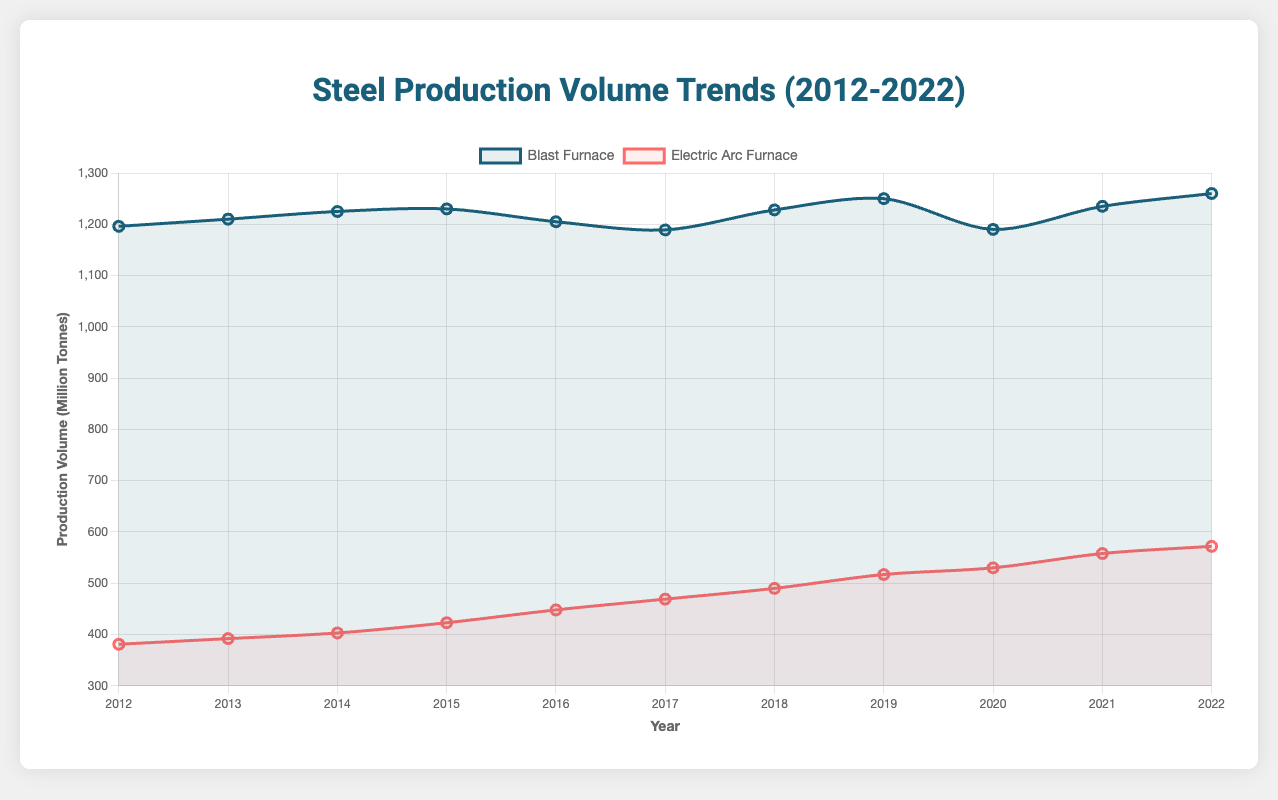What is the overall trend observed for the Electric Arc Furnace production volume from 2012 to 2022? The Electric Arc Furnace production volume shows a steady increase each year from 381 million tonnes in 2012 to 572 million tonnes in 2022.
Answer: Steady increase Which technology type had the highest production volume in 2022? To determine which technology type had the highest production volume, compare the values for 2022: Blast Furnace is 1260 million tonnes and Electric Arc Furnace is 572 million tonnes. The higher value is for Blast Furnace.
Answer: Blast Furnace By how much did the production volume of the Blast Furnace change from 2017 to 2022? Subtract the 2017 value (1189 million tonnes) from the 2022 value (1260 million tonnes) to find the change: 1260 - 1189 = 71 million tonnes.
Answer: 71 million tonnes Which year had the largest increase in production volume for Electric Arc Furnace compared to the previous year? Calculate the yearly differences for Electric Arc Furnace production volumes and identify the maximum increase: The largest increase is from 2019 to 2020 (530 - 517 = 13 million tonnes).
Answer: 2020 How does the production volume trend for Blast Furnace compare between 2016 and 2017? Comparing the values, Blast Furnace production decreased from 2016 (1205 million tonnes) to 2017 (1189 million tonnes).
Answer: Decreased What is the average production volume for Electric Arc Furnace over the decade (2012-2022)? Sum all Electric Arc Furnace production volumes from 2012 to 2022 and divide by the number of years: (381 + 392 + 403 + 423 + 448 + 469 + 490 + 517 + 530 + 558 + 572) / 11 = 456.18 million tonnes (approx).
Answer: 456.18 million tonnes What technological type had a higher production increase from 2019 to 2022? Calculate the difference in production for both technologies between 2019 and 2022: Blast Furnace (1260 - 1250 = 10 million tonnes) and Electric Arc Furnace (572 - 517 = 55 million tonnes). Electric Arc Furnace has a higher increase.
Answer: Electric Arc Furnace During which year did the Blast Furnace production volume fall below 1200 million tonnes? Examine each year's production volume for Blast Furnace. In 2020, it fell to 1190 million tonnes.
Answer: 2020 In 2015, what was the difference in production volumes between the two technology types? Subtract the Electric Arc Furnace value from the Blast Furnace value in 2015: 1230 - 423 = 807 million tonnes.
Answer: 807 million tonnes Between 2018 and 2019, what was the percentage increase in production volume for Electric Arc Furnace? Calculate the percentage increase using values for 2018 and 2019: ((517 - 490) / 490) * 100 = 5.51% (approx).
Answer: 5.51% 